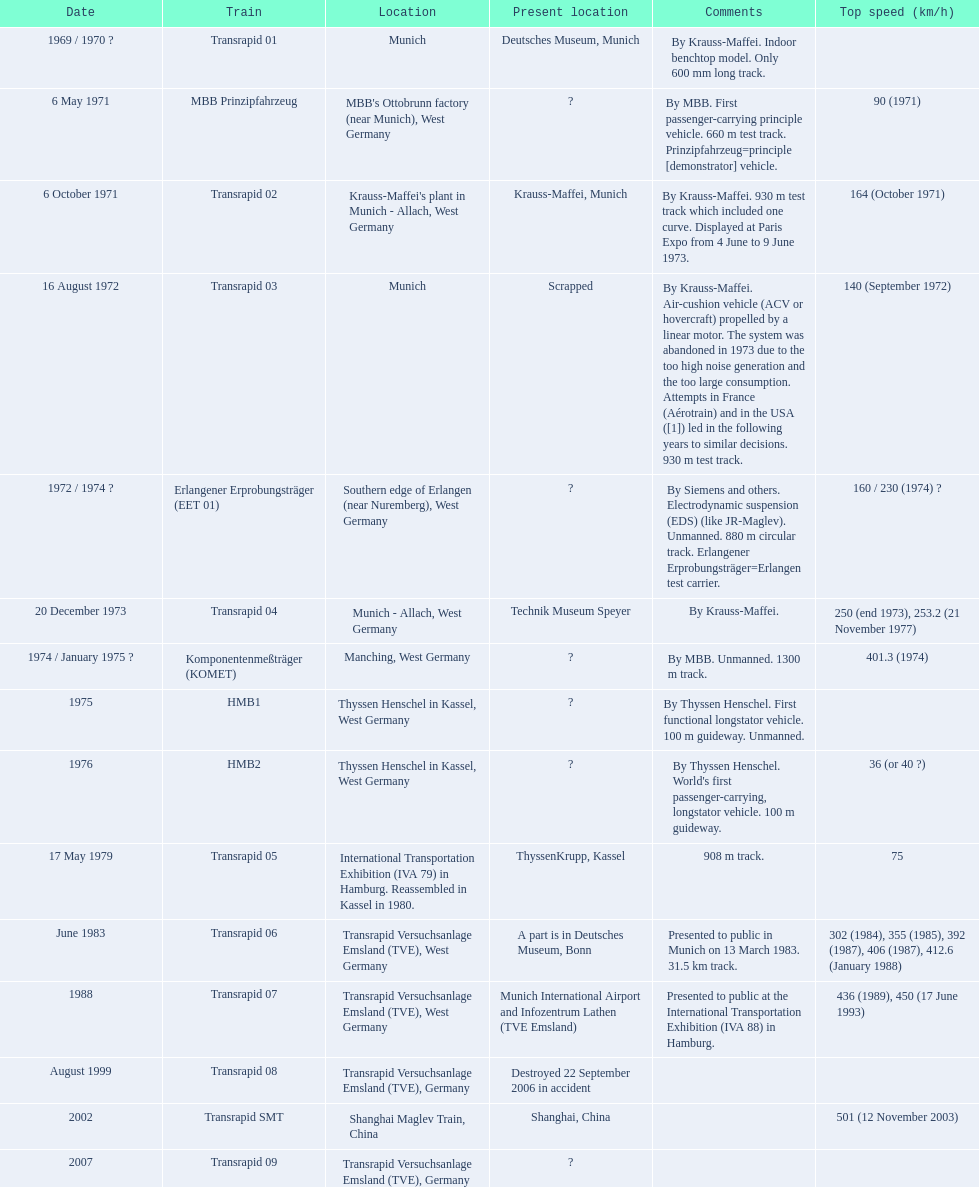Which trains exceeded a top speed of 400+? Komponentenmeßträger (KOMET), Transrapid 07, Transrapid SMT. How about 500+? Transrapid SMT. 